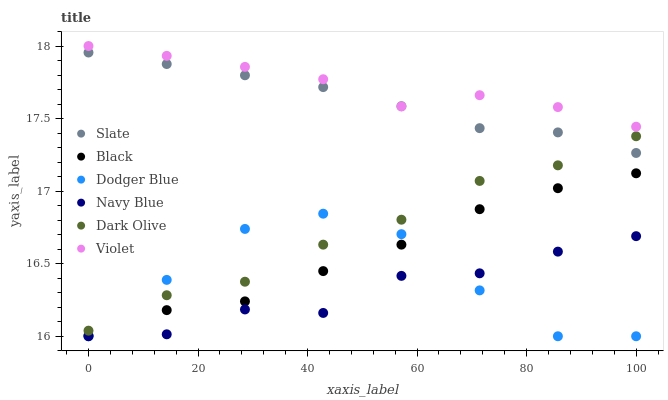Does Navy Blue have the minimum area under the curve?
Answer yes or no. Yes. Does Violet have the maximum area under the curve?
Answer yes or no. Yes. Does Slate have the minimum area under the curve?
Answer yes or no. No. Does Slate have the maximum area under the curve?
Answer yes or no. No. Is Slate the smoothest?
Answer yes or no. Yes. Is Dodger Blue the roughest?
Answer yes or no. Yes. Is Dark Olive the smoothest?
Answer yes or no. No. Is Dark Olive the roughest?
Answer yes or no. No. Does Navy Blue have the lowest value?
Answer yes or no. Yes. Does Slate have the lowest value?
Answer yes or no. No. Does Violet have the highest value?
Answer yes or no. Yes. Does Slate have the highest value?
Answer yes or no. No. Is Black less than Slate?
Answer yes or no. Yes. Is Dark Olive greater than Black?
Answer yes or no. Yes. Does Black intersect Dodger Blue?
Answer yes or no. Yes. Is Black less than Dodger Blue?
Answer yes or no. No. Is Black greater than Dodger Blue?
Answer yes or no. No. Does Black intersect Slate?
Answer yes or no. No. 